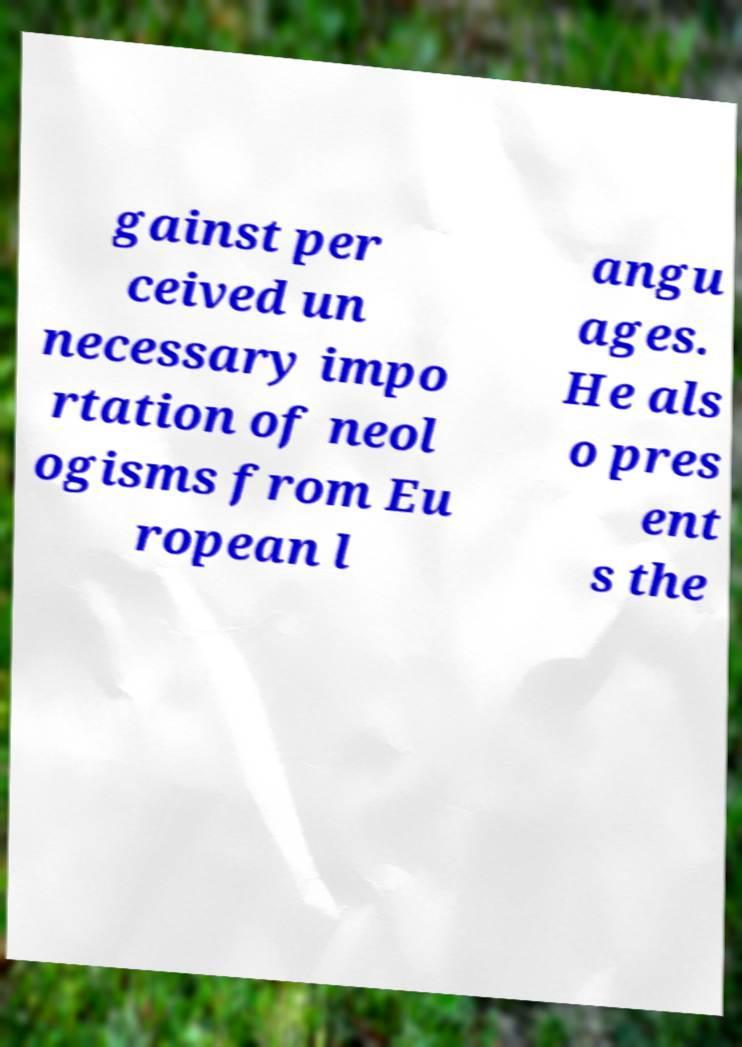Please read and relay the text visible in this image. What does it say? gainst per ceived un necessary impo rtation of neol ogisms from Eu ropean l angu ages. He als o pres ent s the 